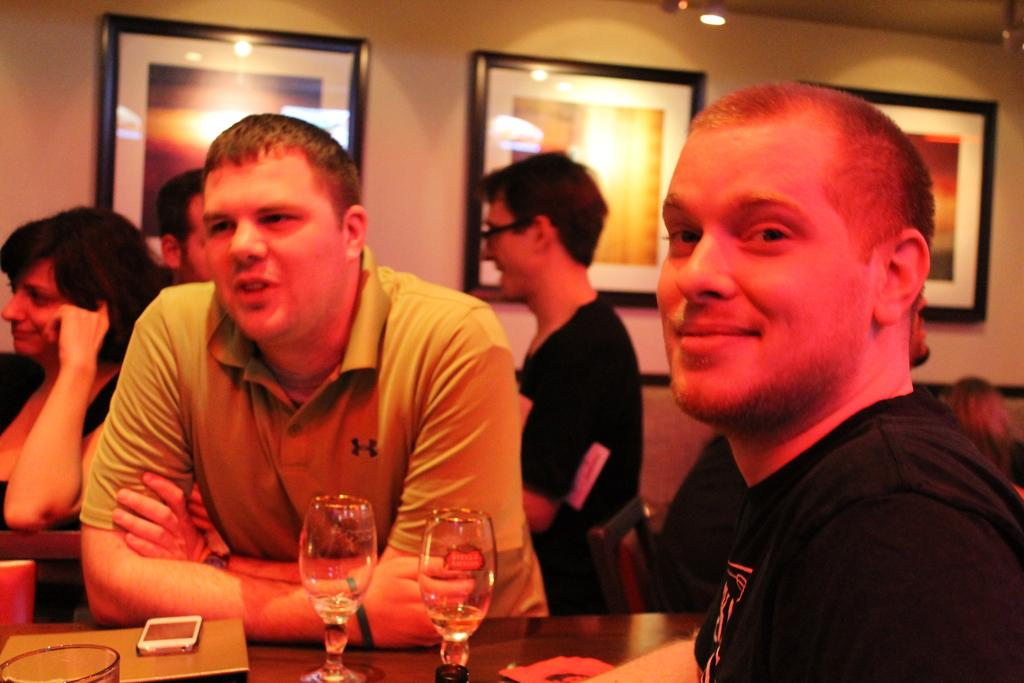How many people are in the room? There are people in the room, but the exact number is not specified in the facts. What is in the room that people might gather around? There is a table in the room, which could be a gathering point. What can be found on the table? There are glasses on the table, as well as other objects. What is visible on the wall in the background? There are three photo frames on a wall in the background. What type of rock is being used as a paperweight on the table? There is no rock present on the table in the image. What kind of metal is used to make the chairs in the room? The facts do not mention the material of the chairs. 